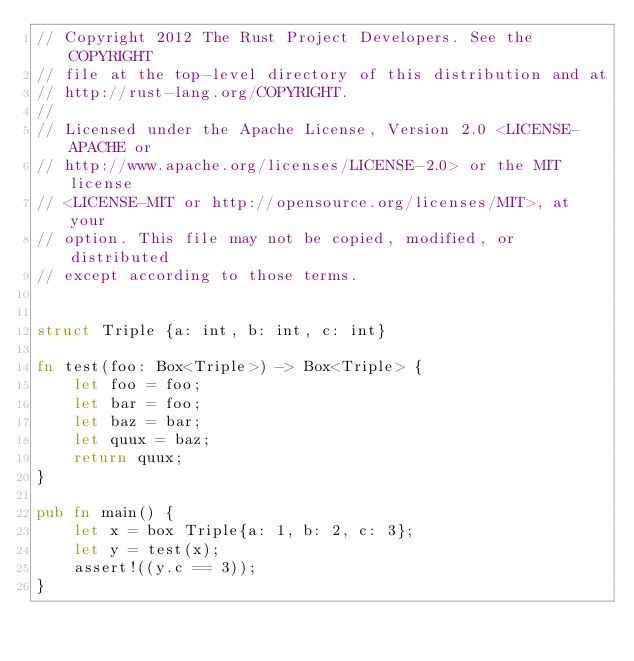<code> <loc_0><loc_0><loc_500><loc_500><_Rust_>// Copyright 2012 The Rust Project Developers. See the COPYRIGHT
// file at the top-level directory of this distribution and at
// http://rust-lang.org/COPYRIGHT.
//
// Licensed under the Apache License, Version 2.0 <LICENSE-APACHE or
// http://www.apache.org/licenses/LICENSE-2.0> or the MIT license
// <LICENSE-MIT or http://opensource.org/licenses/MIT>, at your
// option. This file may not be copied, modified, or distributed
// except according to those terms.


struct Triple {a: int, b: int, c: int}

fn test(foo: Box<Triple>) -> Box<Triple> {
    let foo = foo;
    let bar = foo;
    let baz = bar;
    let quux = baz;
    return quux;
}

pub fn main() {
    let x = box Triple{a: 1, b: 2, c: 3};
    let y = test(x);
    assert!((y.c == 3));
}
</code> 